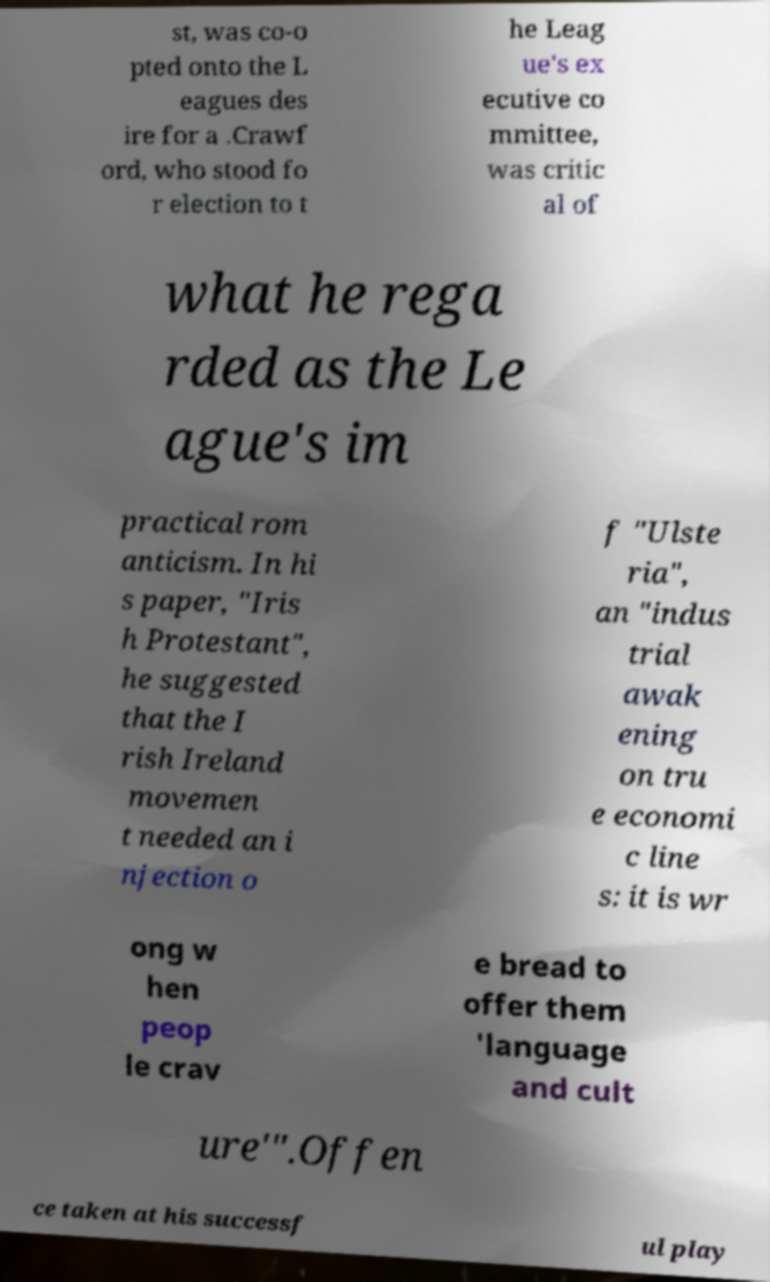There's text embedded in this image that I need extracted. Can you transcribe it verbatim? st, was co-o pted onto the L eagues des ire for a .Crawf ord, who stood fo r election to t he Leag ue's ex ecutive co mmittee, was critic al of what he rega rded as the Le ague's im practical rom anticism. In hi s paper, "Iris h Protestant", he suggested that the I rish Ireland movemen t needed an i njection o f "Ulste ria", an "indus trial awak ening on tru e economi c line s: it is wr ong w hen peop le crav e bread to offer them 'language and cult ure'".Offen ce taken at his successf ul play 